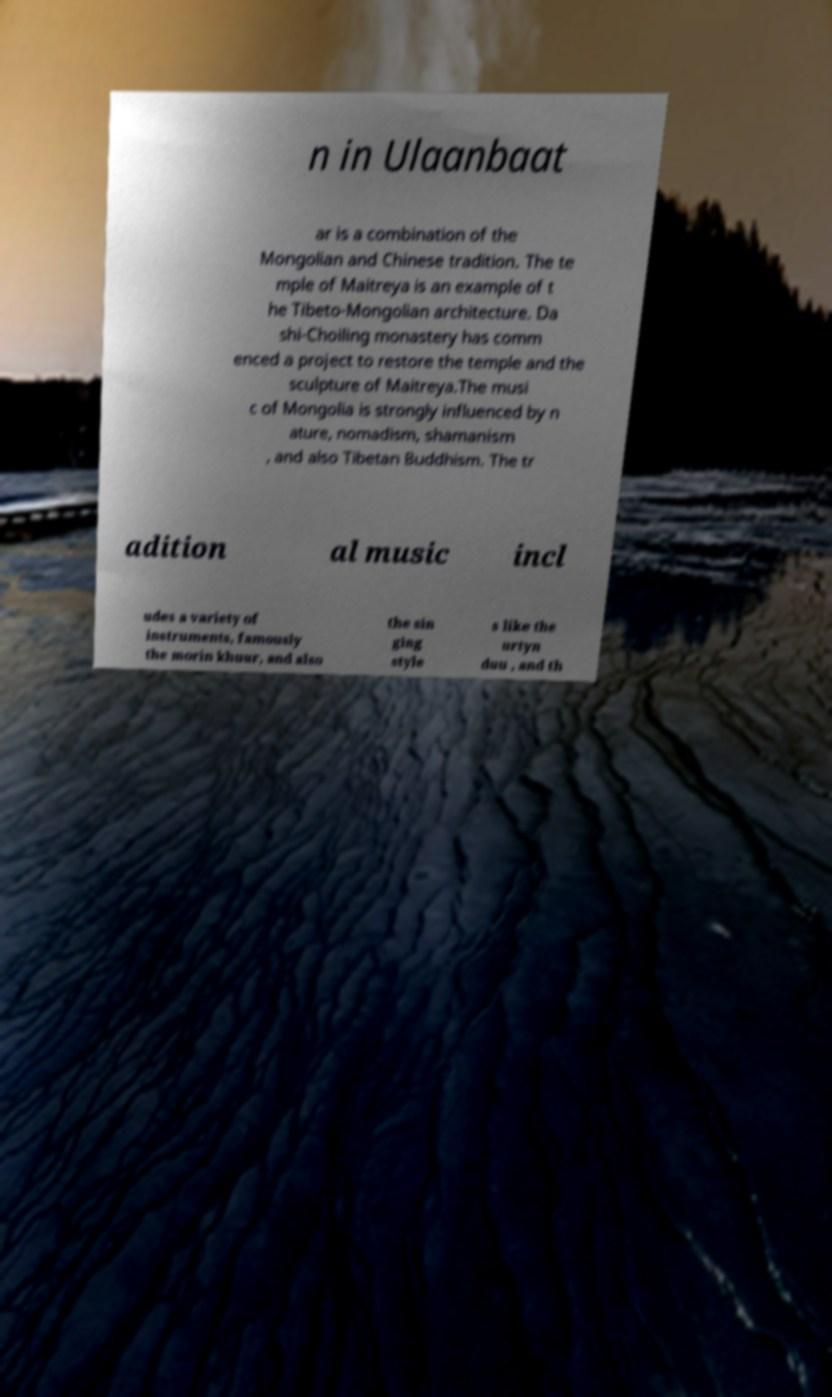Please read and relay the text visible in this image. What does it say? n in Ulaanbaat ar is a combination of the Mongolian and Chinese tradition. The te mple of Maitreya is an example of t he Tibeto-Mongolian architecture. Da shi-Choiling monastery has comm enced a project to restore the temple and the sculpture of Maitreya.The musi c of Mongolia is strongly influenced by n ature, nomadism, shamanism , and also Tibetan Buddhism. The tr adition al music incl udes a variety of instruments, famously the morin khuur, and also the sin ging style s like the urtyn duu , and th 